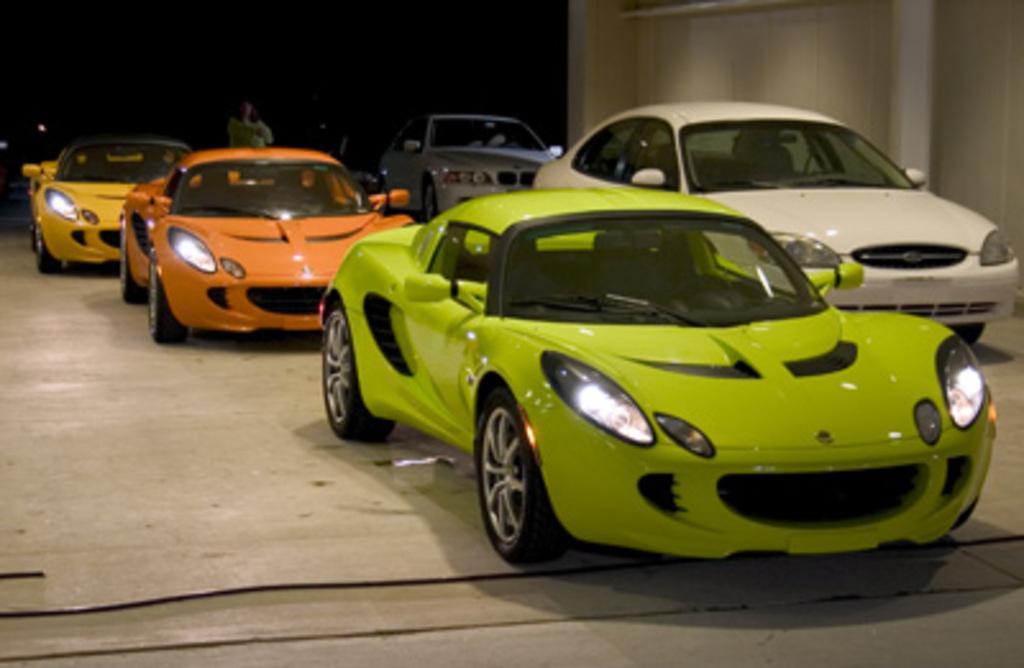How would you summarize this image in a sentence or two? In this image in the center there are some cars, and in the background there is one person standing. On the right side there is wall, at the bottom there is floor. On the floor there are some wires and there is black background. 